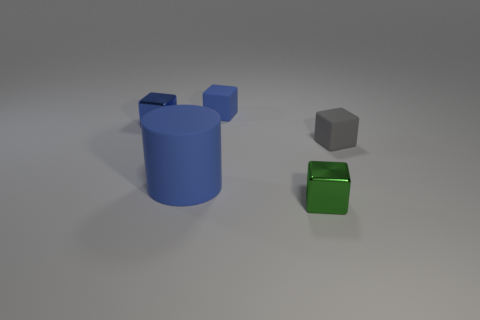There is a tiny thing that is behind the green object and in front of the small blue shiny cube; what shape is it? The shape behind the green object and in front of the small blue cube is a small gray cube. It shares the cubic structure of having equal-width sides and sharp edges that define its form. 